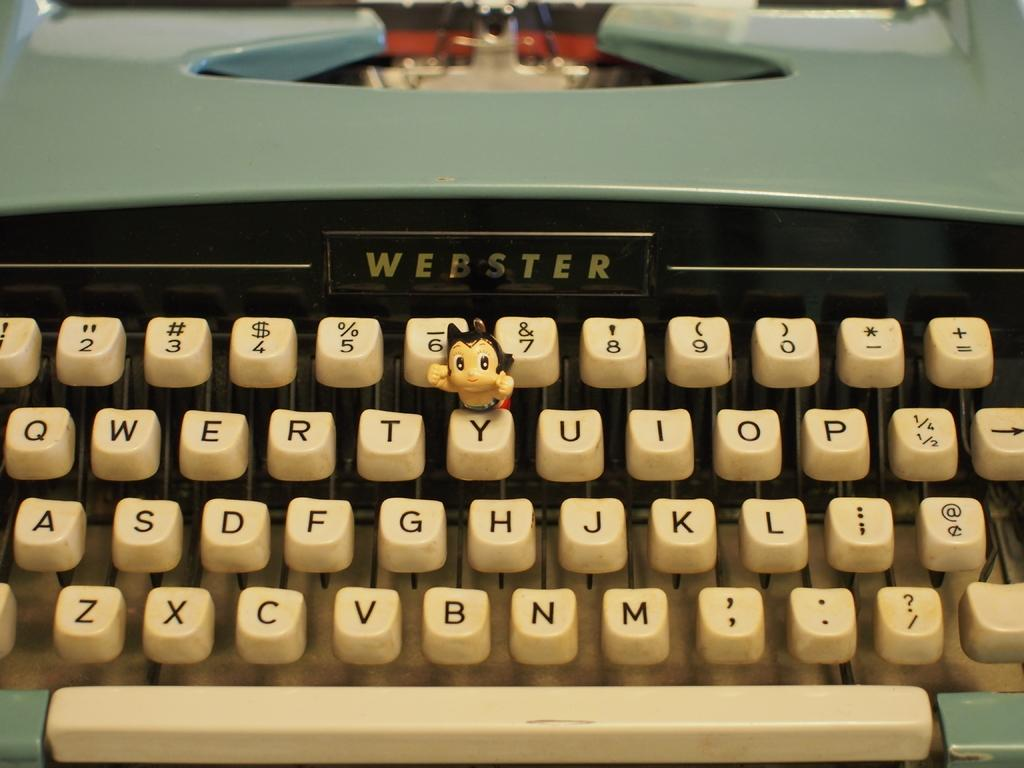Provide a one-sentence caption for the provided image. An old Webster type writer is a figurine on the Y key. 